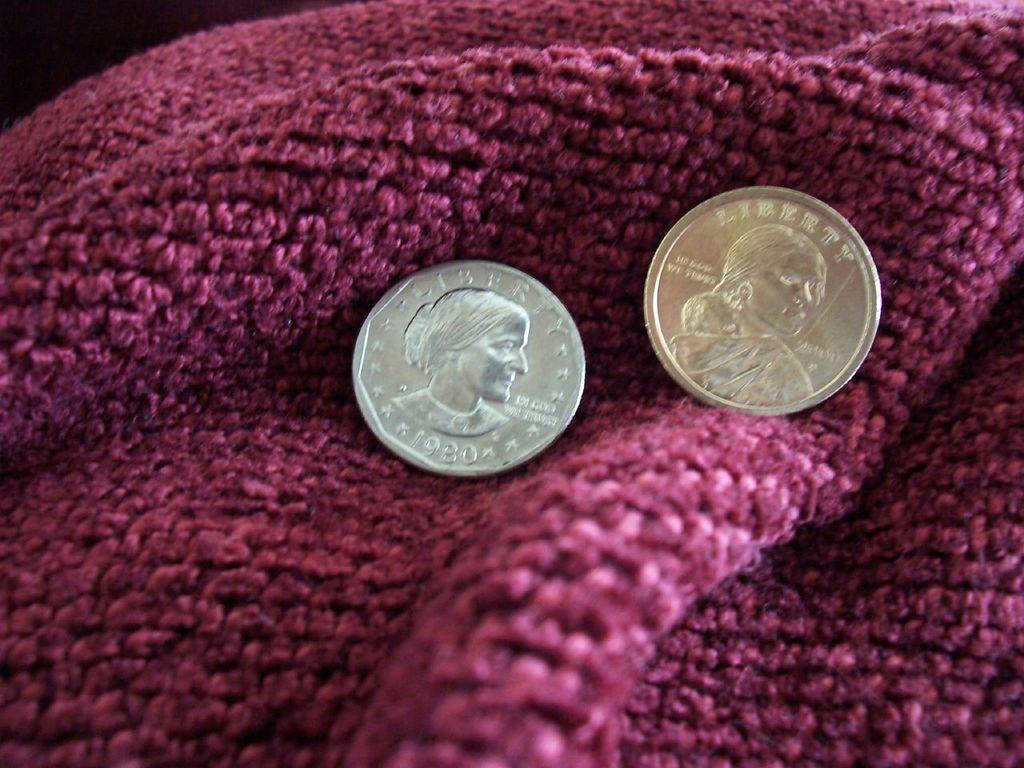<image>
Render a clear and concise summary of the photo. Two Liberty coins are sitting on a pink blanket. 